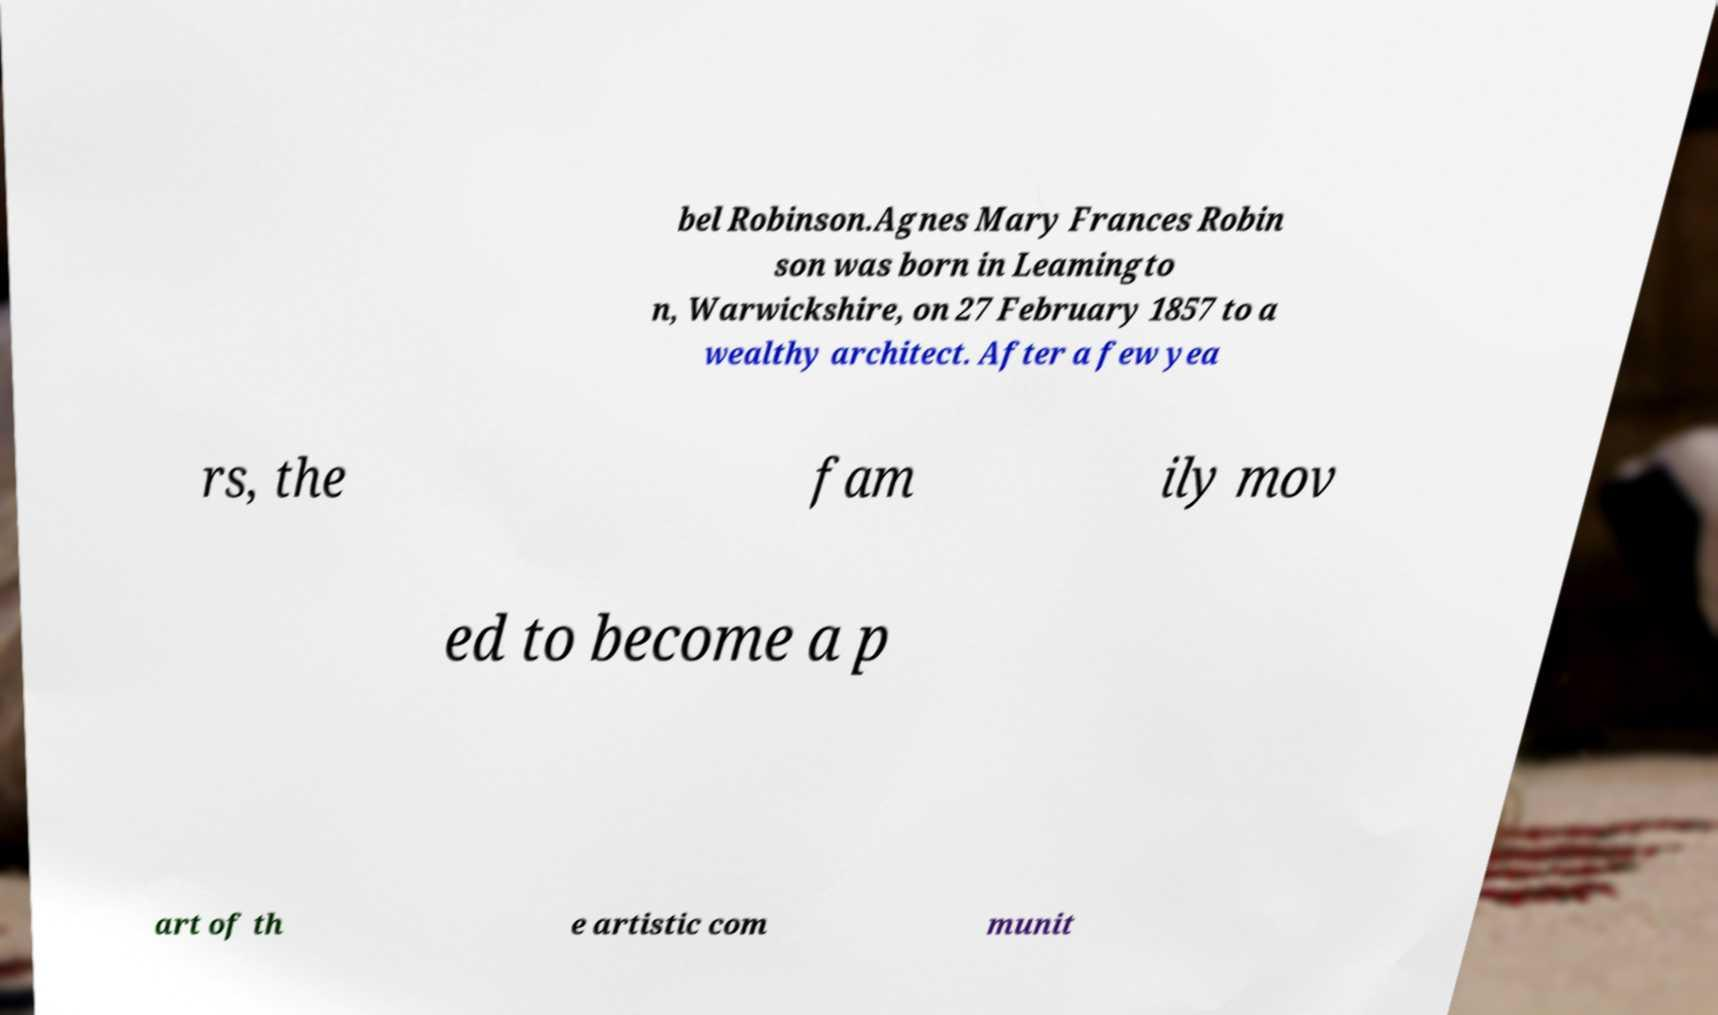Could you assist in decoding the text presented in this image and type it out clearly? bel Robinson.Agnes Mary Frances Robin son was born in Leamingto n, Warwickshire, on 27 February 1857 to a wealthy architect. After a few yea rs, the fam ily mov ed to become a p art of th e artistic com munit 